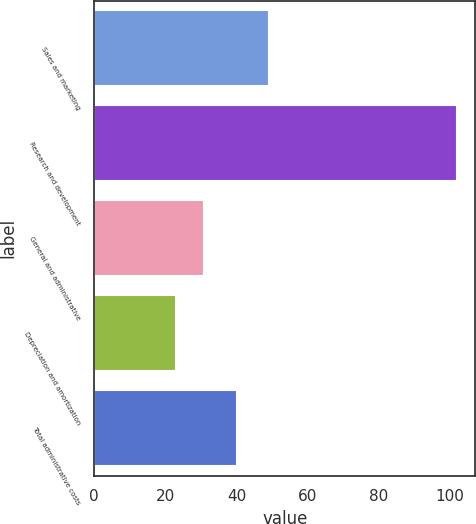<chart> <loc_0><loc_0><loc_500><loc_500><bar_chart><fcel>Sales and marketing<fcel>Research and development<fcel>General and administrative<fcel>Depreciation and amortization<fcel>Total administrative costs<nl><fcel>49<fcel>102<fcel>30.9<fcel>23<fcel>40<nl></chart> 